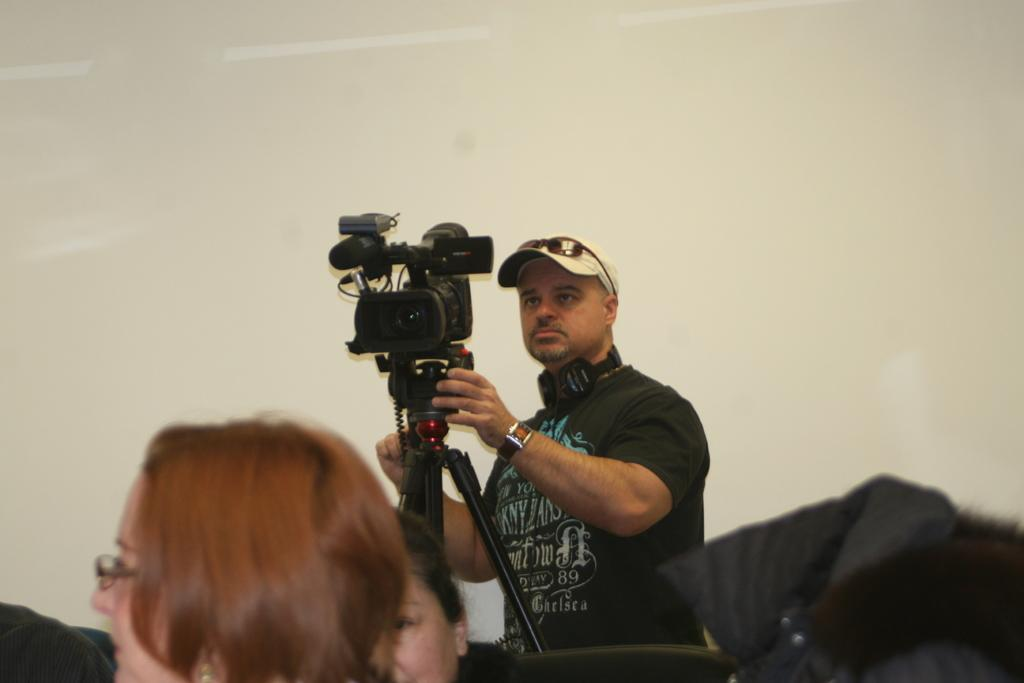What is the man in the image doing? The man is standing and adjusting a camera in the image. How is the camera positioned in the image? The camera is on a tripod stand in the image. Can you describe the people visible at the bottom of the image? There are people visible at the bottom of the image, but their specific actions or features are not mentioned in the provided facts. What is visible in the background of the image? There is a wall in the background of the image. What type of bird can be seen flying over the man's head in the image? There is no bird visible in the image; it only features a man adjusting a camera on a tripod stand, people at the bottom, and a wall in the background. 